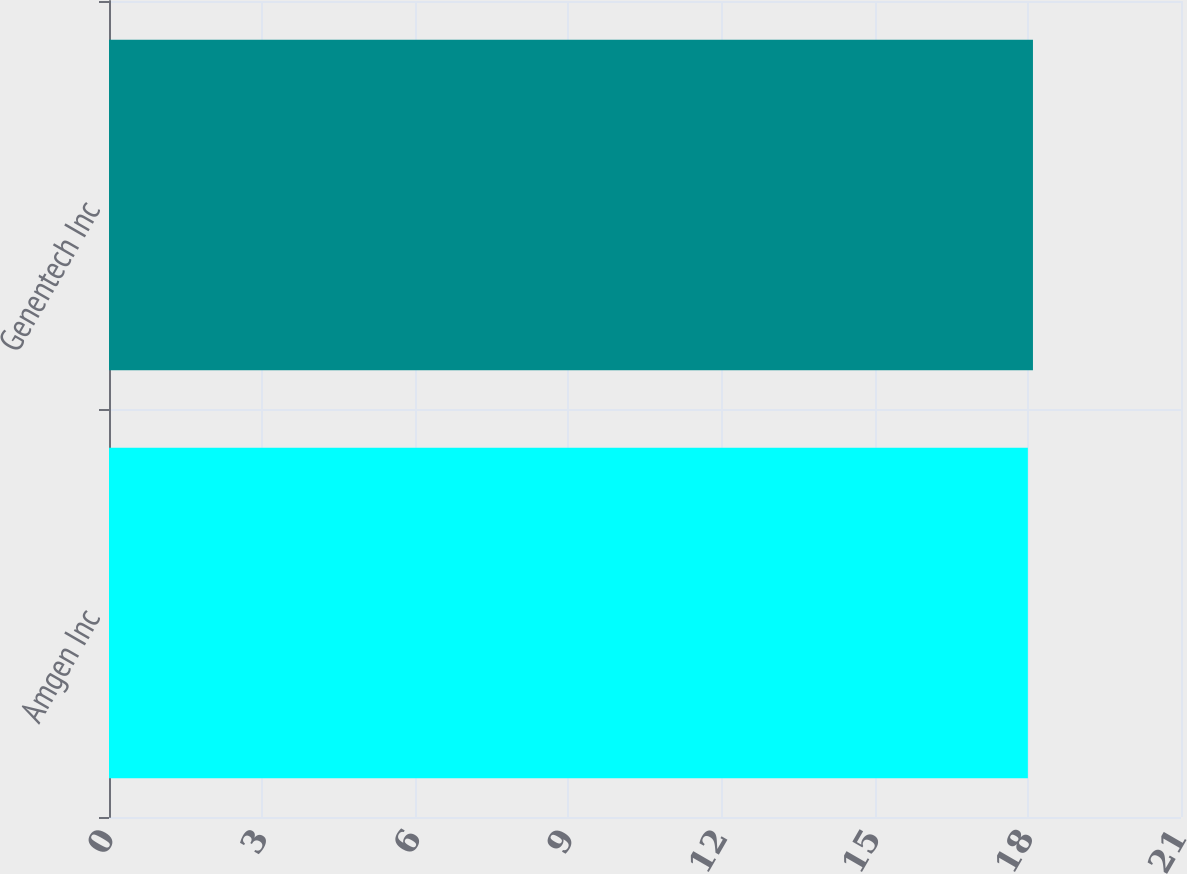Convert chart to OTSL. <chart><loc_0><loc_0><loc_500><loc_500><bar_chart><fcel>Amgen Inc<fcel>Genentech Inc<nl><fcel>18<fcel>18.1<nl></chart> 